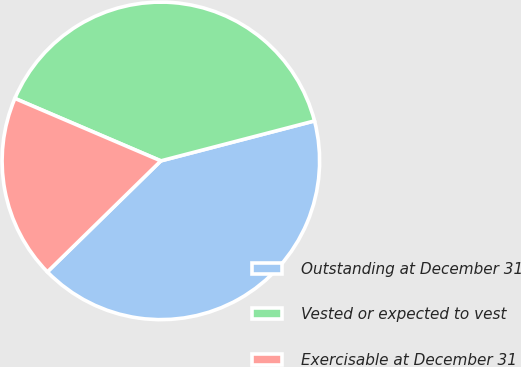Convert chart. <chart><loc_0><loc_0><loc_500><loc_500><pie_chart><fcel>Outstanding at December 31<fcel>Vested or expected to vest<fcel>Exercisable at December 31<nl><fcel>41.72%<fcel>39.51%<fcel>18.76%<nl></chart> 